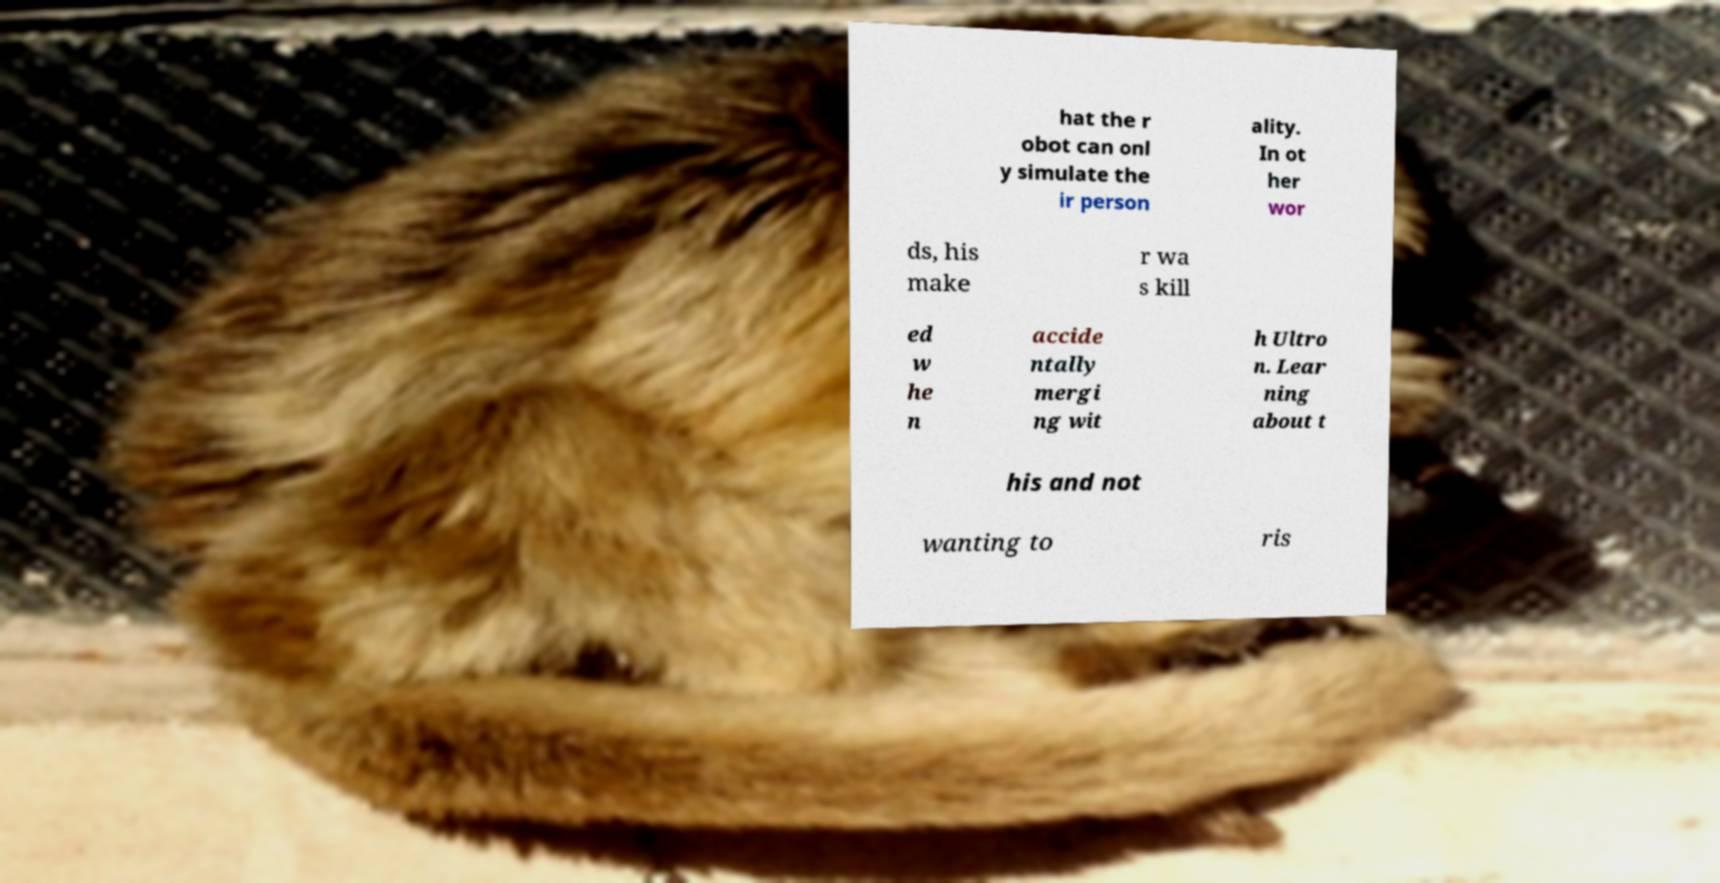Please read and relay the text visible in this image. What does it say? hat the r obot can onl y simulate the ir person ality. In ot her wor ds, his make r wa s kill ed w he n accide ntally mergi ng wit h Ultro n. Lear ning about t his and not wanting to ris 